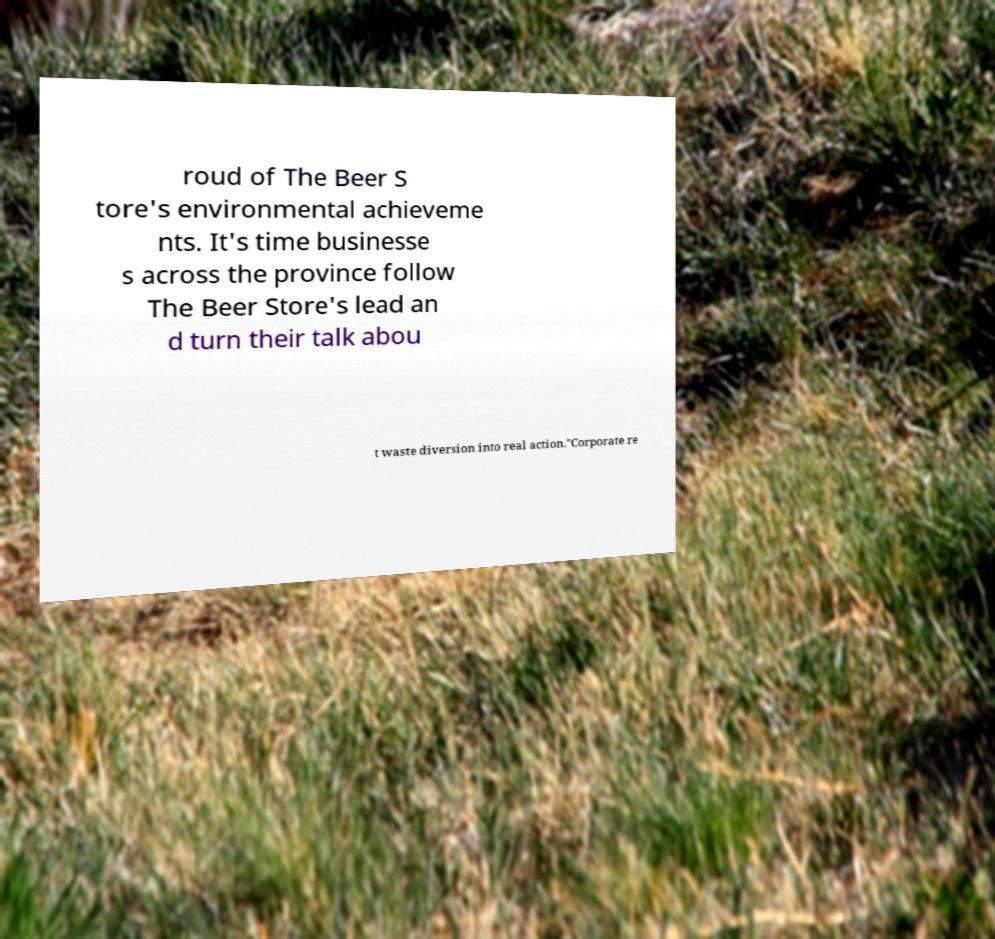Can you accurately transcribe the text from the provided image for me? roud of The Beer S tore's environmental achieveme nts. It's time businesse s across the province follow The Beer Store's lead an d turn their talk abou t waste diversion into real action."Corporate re 